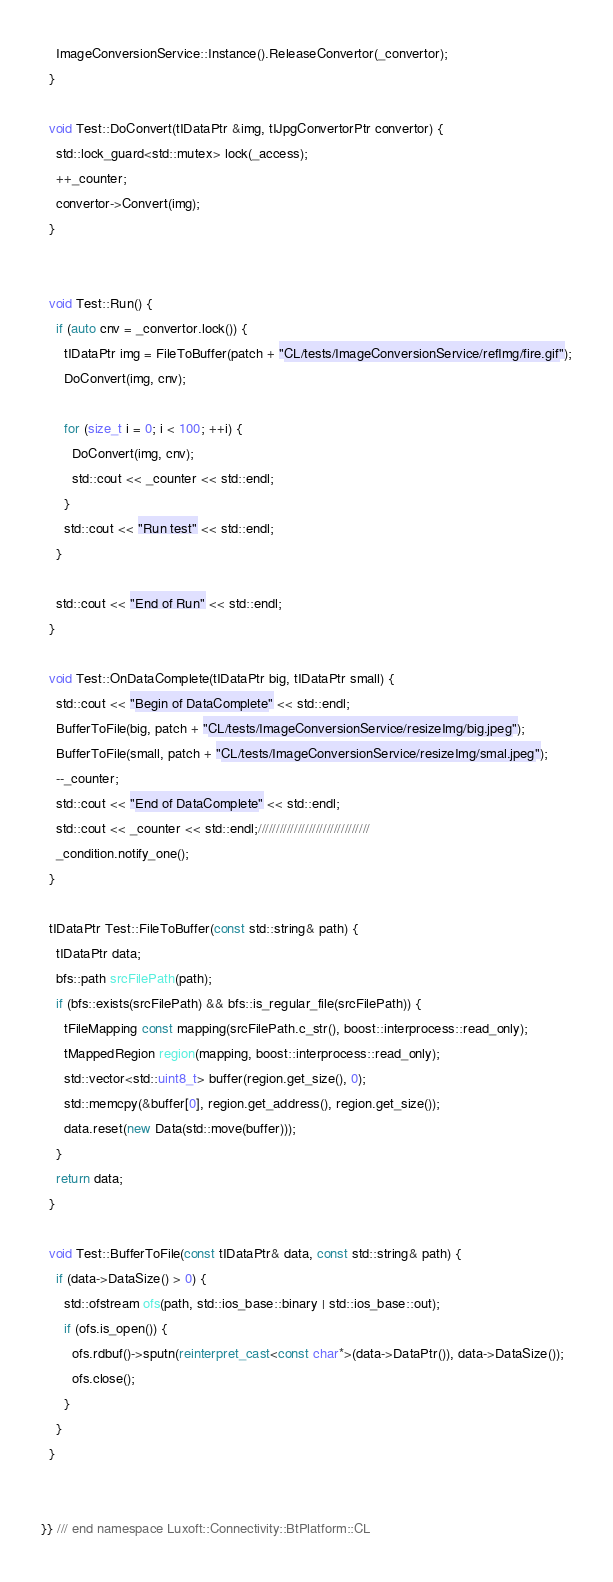<code> <loc_0><loc_0><loc_500><loc_500><_C++_>    ImageConversionService::Instance().ReleaseConvertor(_convertor);
  }

  void Test::DoConvert(tIDataPtr &img, tIJpgConvertorPtr convertor) {
    std::lock_guard<std::mutex> lock(_access);
    ++_counter;
    convertor->Convert(img);
  }


  void Test::Run() {
    if (auto cnv = _convertor.lock()) {
      tIDataPtr img = FileToBuffer(patch + "CL/tests/ImageConversionService/refImg/fire.gif");
      DoConvert(img, cnv);

      for (size_t i = 0; i < 100; ++i) {
        DoConvert(img, cnv);
        std::cout << _counter << std::endl;
      }
	  std::cout << "Run test" << std::endl;
    }

    std::cout << "End of Run" << std::endl;
  }

  void Test::OnDataComplete(tIDataPtr big, tIDataPtr small) {
    std::cout << "Begin of DataComplete" << std::endl;
    BufferToFile(big, patch + "CL/tests/ImageConversionService/resizeImg/big.jpeg");
    BufferToFile(small, patch + "CL/tests/ImageConversionService/resizeImg/smal.jpeg");
    --_counter;
    std::cout << "End of DataComplete" << std::endl;
    std::cout << _counter << std::endl;///////////////////////////////
    _condition.notify_one();
  }

  tIDataPtr Test::FileToBuffer(const std::string& path) {
    tIDataPtr data;
    bfs::path srcFilePath(path);
    if (bfs::exists(srcFilePath) && bfs::is_regular_file(srcFilePath)) {
      tFileMapping const mapping(srcFilePath.c_str(), boost::interprocess::read_only);
      tMappedRegion region(mapping, boost::interprocess::read_only);
      std::vector<std::uint8_t> buffer(region.get_size(), 0);
      std::memcpy(&buffer[0], region.get_address(), region.get_size());
      data.reset(new Data(std::move(buffer)));
    }
    return data;
  }

  void Test::BufferToFile(const tIDataPtr& data, const std::string& path) {
    if (data->DataSize() > 0) {
      std::ofstream ofs(path, std::ios_base::binary | std::ios_base::out);
      if (ofs.is_open()) {
        ofs.rdbuf()->sputn(reinterpret_cast<const char*>(data->DataPtr()), data->DataSize());
        ofs.close();
      }
    }
  }


}} /// end namespace Luxoft::Connectivity::BtPlatform::CL
</code> 